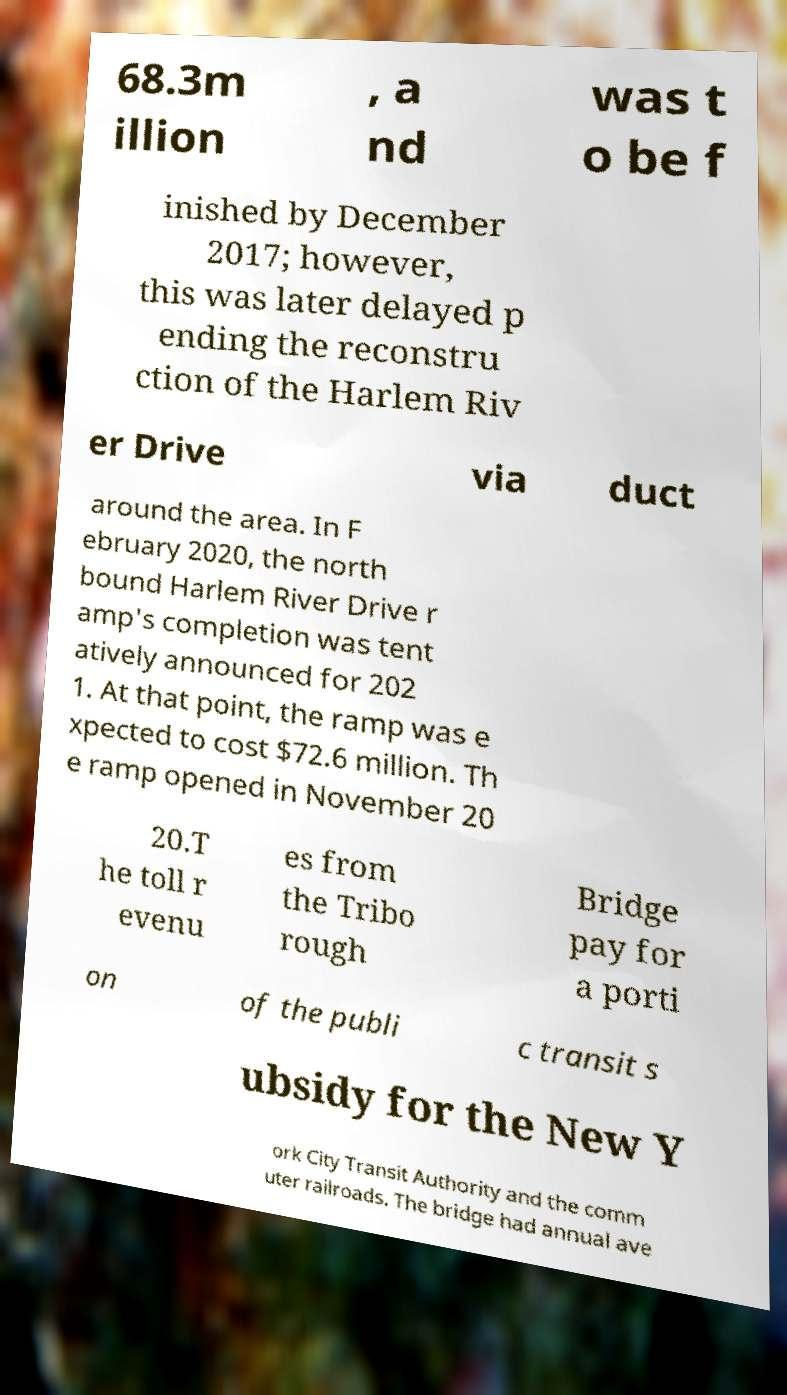There's text embedded in this image that I need extracted. Can you transcribe it verbatim? 68.3m illion , a nd was t o be f inished by December 2017; however, this was later delayed p ending the reconstru ction of the Harlem Riv er Drive via duct around the area. In F ebruary 2020, the north bound Harlem River Drive r amp's completion was tent atively announced for 202 1. At that point, the ramp was e xpected to cost $72.6 million. Th e ramp opened in November 20 20.T he toll r evenu es from the Tribo rough Bridge pay for a porti on of the publi c transit s ubsidy for the New Y ork City Transit Authority and the comm uter railroads. The bridge had annual ave 